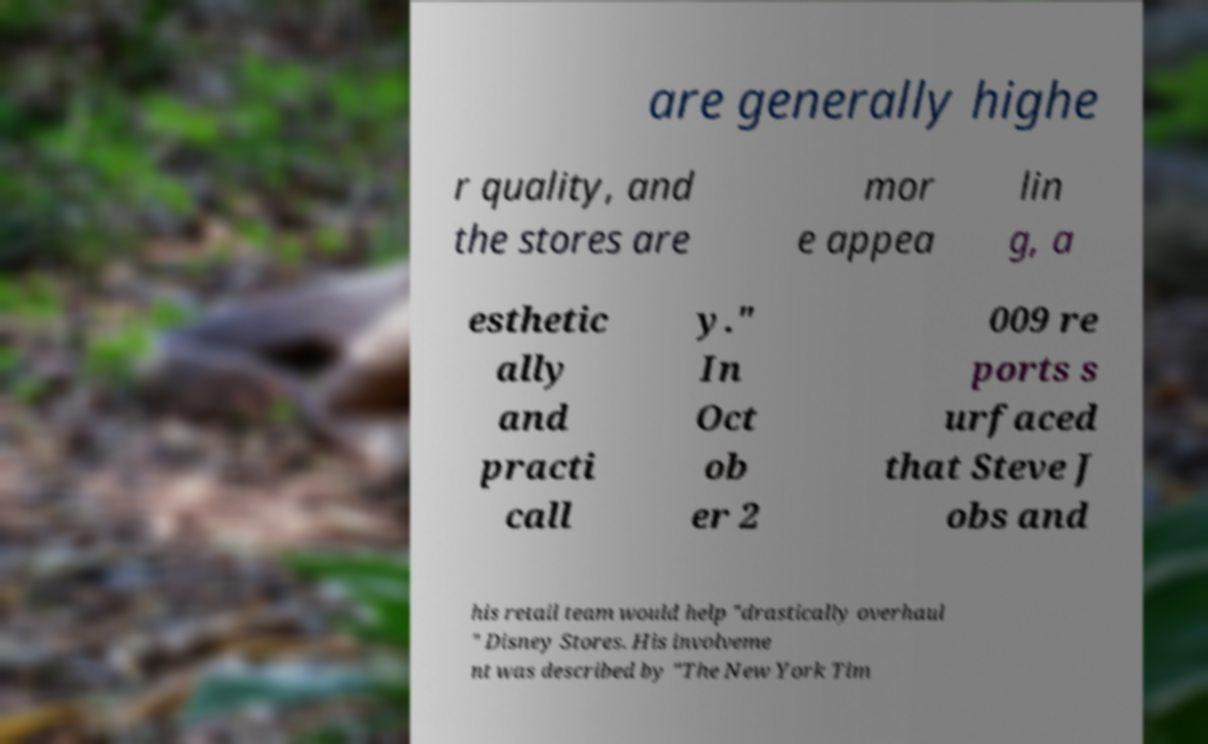Can you accurately transcribe the text from the provided image for me? are generally highe r quality, and the stores are mor e appea lin g, a esthetic ally and practi call y." In Oct ob er 2 009 re ports s urfaced that Steve J obs and his retail team would help "drastically overhaul " Disney Stores. His involveme nt was described by "The New York Tim 